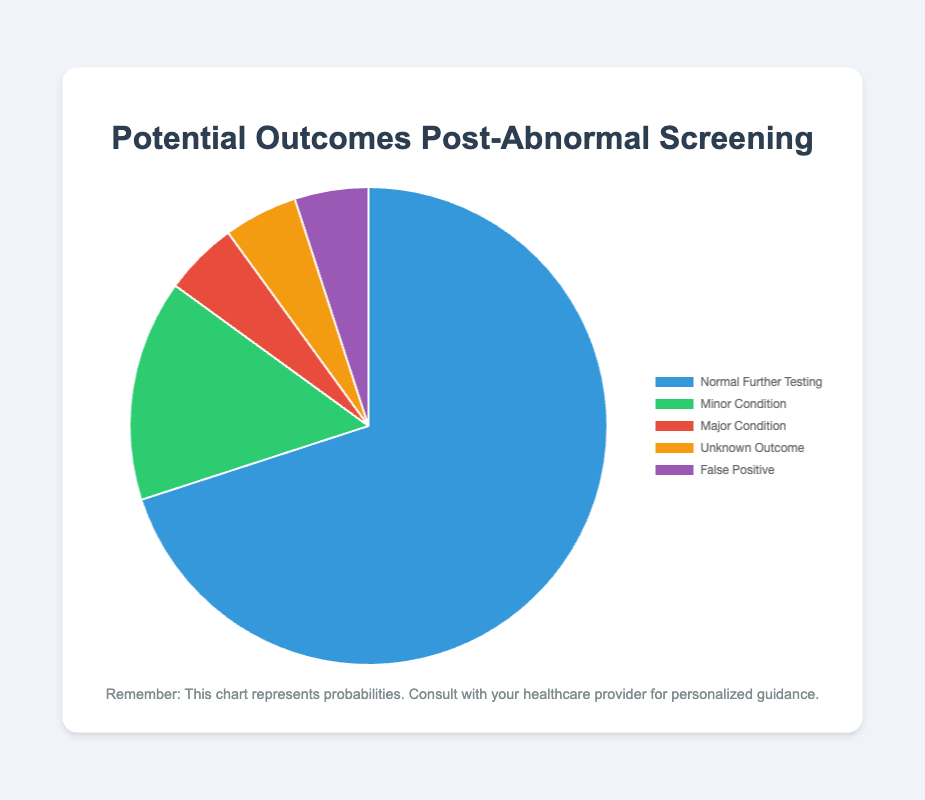What's the most likely outcome post-abnormal screening? The pie chart shows that "Normal Further Testing" has the highest slice. Its probability is 0.70, which is the largest among all outcomes.
Answer: Normal Further Testing What is the combined probability of "Major Condition" and "False Positive"? The probabilities for "Major Condition" and "False Positive" are both 0.05. Adding these probabilities: 0.05 + 0.05 = 0.10.
Answer: 0.10 Which outcome has the smallest probability? The pie chart shows "Major Condition", "Unknown Outcome", and "False Positive" each with the smallest slice, indicating they all share the lowest probability of 0.05.
Answer: Major Condition, Unknown Outcome, False Positive How much more likely is "Normal Further Testing" compared to "Minor Condition"? The probability of "Normal Further Testing" is 0.70, and the probability of "Minor Condition" is 0.15. The difference is 0.70 - 0.15 = 0.55.
Answer: 0.55 What is the total probability of all outcomes excluding "Normal Further Testing"? Adding the probabilities of all outcomes except "Normal Further Testing": 0.15 (Minor Condition) + 0.05 (Major Condition) + 0.05 (Unknown Outcome) + 0.05 (False Positive) equals 0.30.
Answer: 0.30 Describe the visual color representation for "Unknown Outcome". The pie chart uses a specific color for "Unknown Outcome". It is displayed in orange.
Answer: Orange If I combine "Major Condition", "Unknown Outcome", and "False Positive", what percentage do they represent? The combined probability of these three outcomes is: 0.05 (Major Condition) + 0.05 (Unknown Outcome) + 0.05 (False Positive) equals 0.15 or 15%.
Answer: 15% What is the ratio of the probability of "Normal Further Testing" to "Unknown Outcome"? The probability of "Normal Further Testing" is 0.70, and the probability of "Unknown Outcome" is 0.05. The ratio is 0.70 / 0.05 = 14.
Answer: 14 How many outcomes have the same probability, and what is that probability? The pie chart indicates that "Major Condition", "Unknown Outcome", and "False Positive" all have the same probability of 0.05. This makes 3 outcomes.
Answer: 3 outcomes, 0.05 